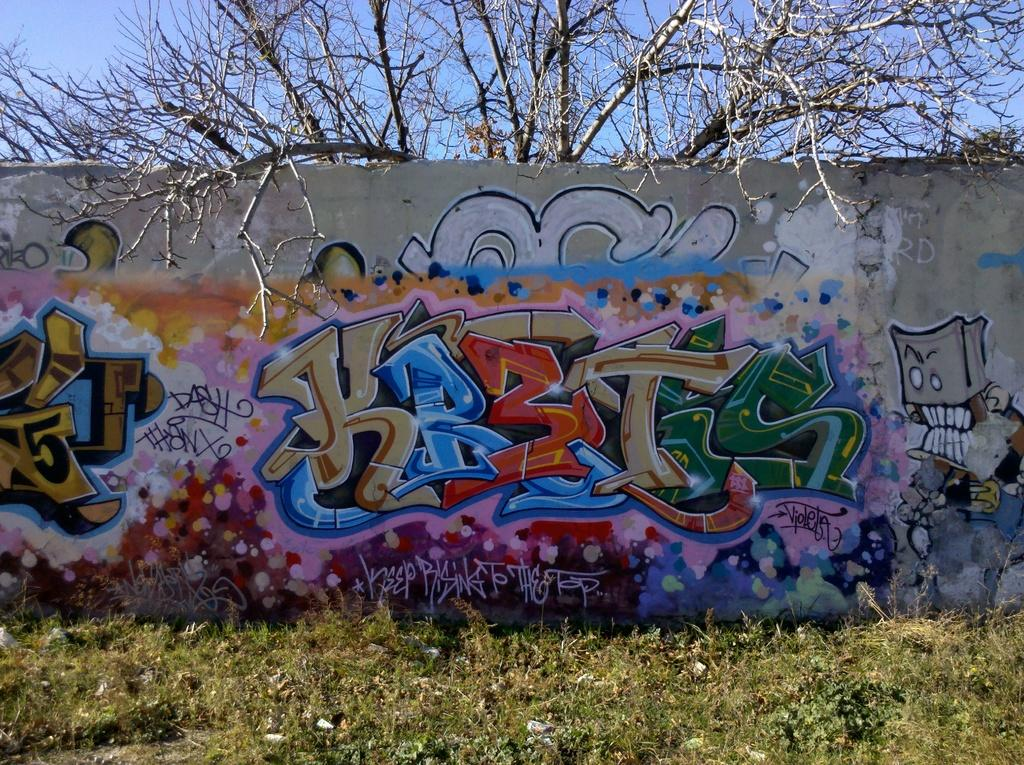What is the main subject in the center of the image? There is a wall in the center of the image. What is on the wall? There is graffiti on the wall. What can be seen in the background of the image? There is a sky and a tree visible in the background of the image. What type of produce is being discussed in the image? There is no produce or discussion present in the image; it features a wall with graffiti and a background with a sky and a tree. 